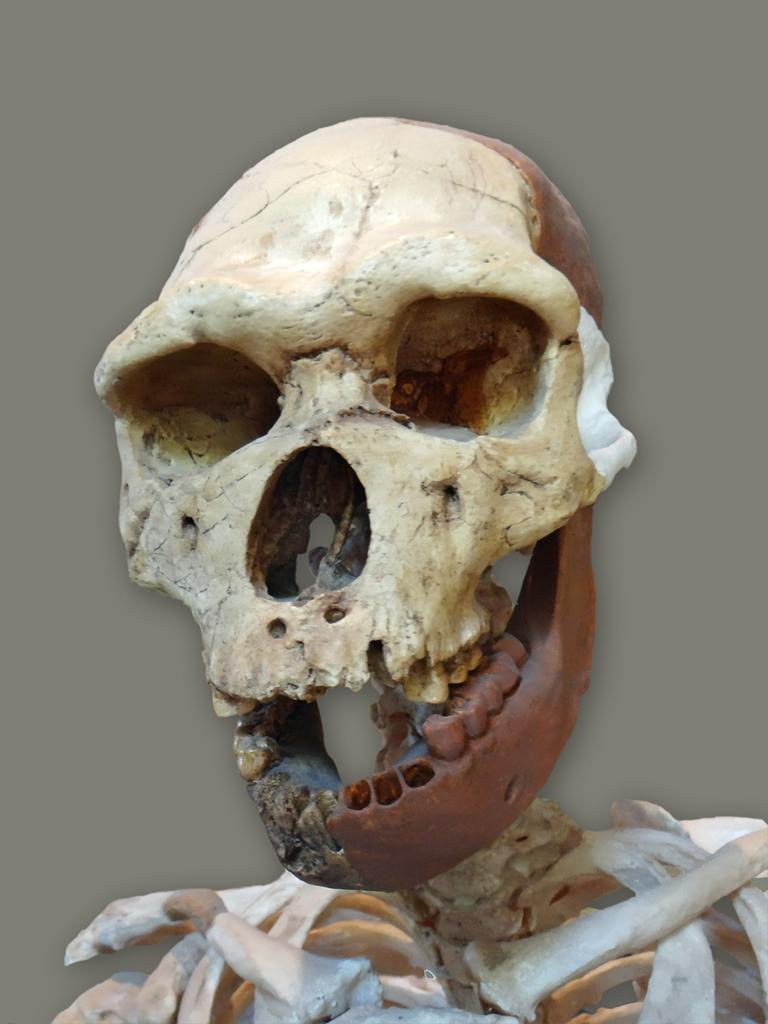What is the main subject in the foreground of the image? There is a skull and a partial skeleton in the foreground of the image. Can you describe the objects in the foreground? The foreground features a skull and a partial skeleton. What else can be seen in the image? There are other objects visible in the background of the image. What type of drum is being played by the farmer in the background of the image? There is no farmer or drum present in the image. 